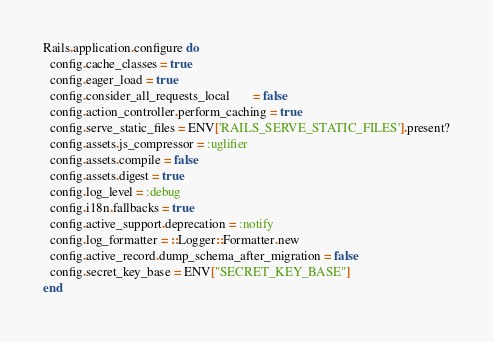<code> <loc_0><loc_0><loc_500><loc_500><_Ruby_>Rails.application.configure do
  config.cache_classes = true
  config.eager_load = true
  config.consider_all_requests_local       = false
  config.action_controller.perform_caching = true
  config.serve_static_files = ENV['RAILS_SERVE_STATIC_FILES'].present?
  config.assets.js_compressor = :uglifier
  config.assets.compile = false
  config.assets.digest = true
  config.log_level = :debug
  config.i18n.fallbacks = true
  config.active_support.deprecation = :notify
  config.log_formatter = ::Logger::Formatter.new
  config.active_record.dump_schema_after_migration = false
  config.secret_key_base = ENV["SECRET_KEY_BASE"]
end
</code> 